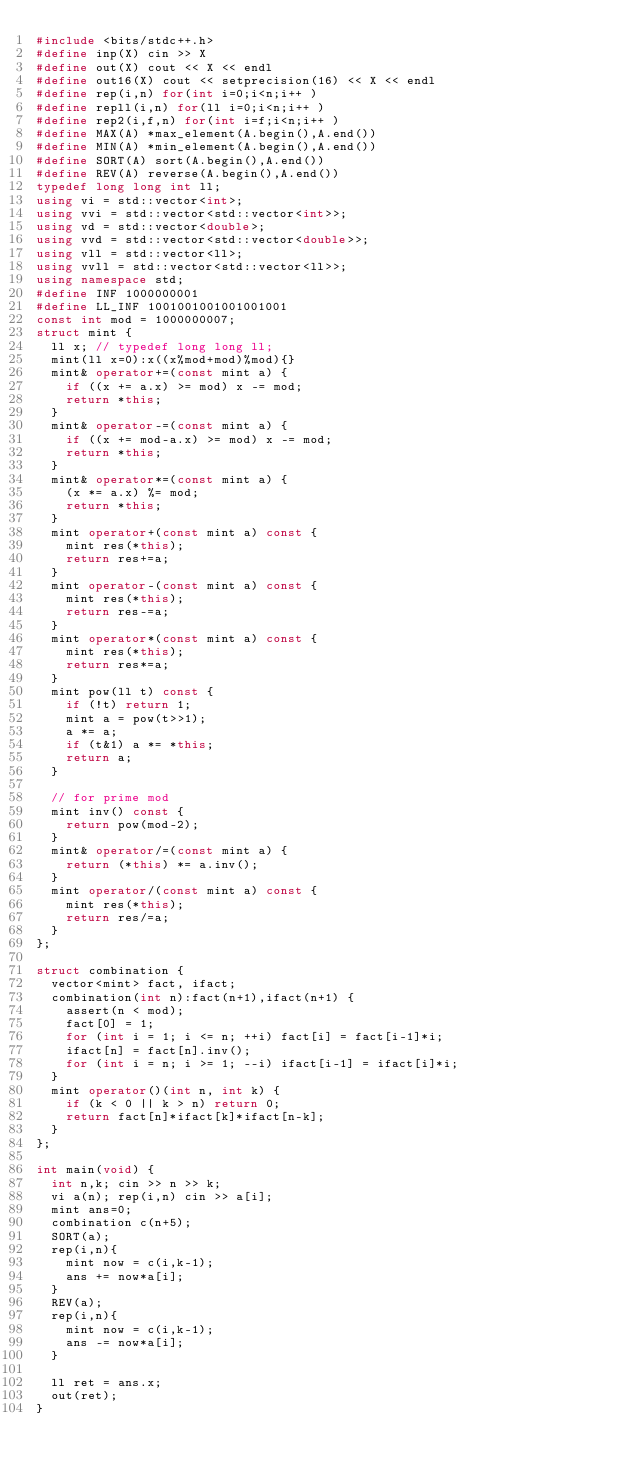Convert code to text. <code><loc_0><loc_0><loc_500><loc_500><_C++_>#include <bits/stdc++.h>
#define inp(X) cin >> X
#define out(X) cout << X << endl
#define out16(X) cout << setprecision(16) << X << endl
#define rep(i,n) for(int i=0;i<n;i++ )
#define repll(i,n) for(ll i=0;i<n;i++ )
#define rep2(i,f,n) for(int i=f;i<n;i++ )
#define MAX(A) *max_element(A.begin(),A.end())
#define MIN(A) *min_element(A.begin(),A.end())
#define SORT(A) sort(A.begin(),A.end())
#define REV(A) reverse(A.begin(),A.end())
typedef long long int ll;
using vi = std::vector<int>;
using vvi = std::vector<std::vector<int>>;
using vd = std::vector<double>;
using vvd = std::vector<std::vector<double>>;
using vll = std::vector<ll>;
using vvll = std::vector<std::vector<ll>>;
using namespace std;
#define INF 1000000001
#define LL_INF 1001001001001001001
const int mod = 1000000007;
struct mint {
  ll x; // typedef long long ll;
  mint(ll x=0):x((x%mod+mod)%mod){}
  mint& operator+=(const mint a) {
    if ((x += a.x) >= mod) x -= mod;
    return *this;
  }
  mint& operator-=(const mint a) {
    if ((x += mod-a.x) >= mod) x -= mod;
    return *this;
  }
  mint& operator*=(const mint a) {
    (x *= a.x) %= mod;
    return *this;
  }
  mint operator+(const mint a) const {
    mint res(*this);
    return res+=a;
  }
  mint operator-(const mint a) const {
    mint res(*this);
    return res-=a;
  }
  mint operator*(const mint a) const {
    mint res(*this);
    return res*=a;
  }
  mint pow(ll t) const {
    if (!t) return 1;
    mint a = pow(t>>1);
    a *= a;
    if (t&1) a *= *this;
    return a;
  }

  // for prime mod
  mint inv() const {
    return pow(mod-2);
  }
  mint& operator/=(const mint a) {
    return (*this) *= a.inv();
  }
  mint operator/(const mint a) const {
    mint res(*this);
    return res/=a;
  }
};

struct combination {
  vector<mint> fact, ifact;
  combination(int n):fact(n+1),ifact(n+1) {
    assert(n < mod);
    fact[0] = 1;
    for (int i = 1; i <= n; ++i) fact[i] = fact[i-1]*i;
    ifact[n] = fact[n].inv();
    for (int i = n; i >= 1; --i) ifact[i-1] = ifact[i]*i;
  }
  mint operator()(int n, int k) {
    if (k < 0 || k > n) return 0;
    return fact[n]*ifact[k]*ifact[n-k];
  }
};

int main(void) {
	int n,k; cin >> n >> k;
	vi a(n); rep(i,n) cin >> a[i];
	mint ans=0;
	combination c(n+5);	
	SORT(a);	
	rep(i,n){
		mint now = c(i,k-1);
		ans += now*a[i];
	}
	REV(a);	
	rep(i,n){
		mint now = c(i,k-1);
		ans -= now*a[i];
	}
	
	ll ret = ans.x;
	out(ret);
}


</code> 